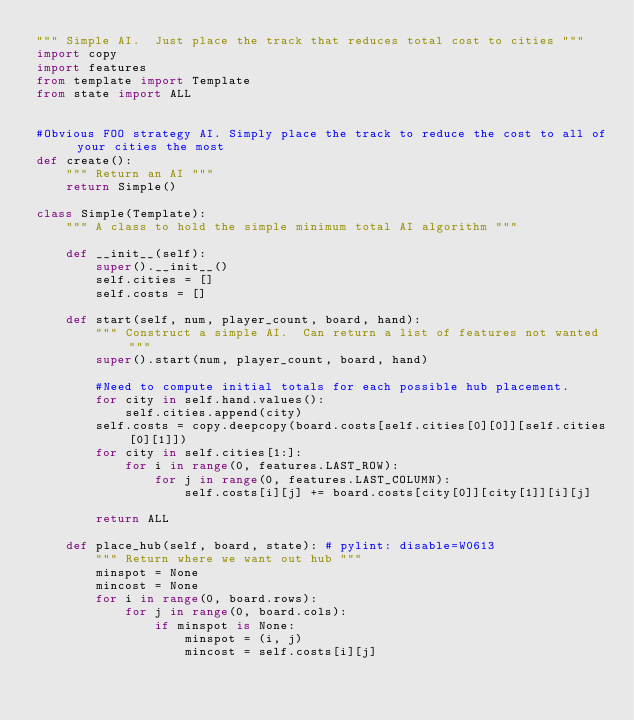Convert code to text. <code><loc_0><loc_0><loc_500><loc_500><_Python_>""" Simple AI.  Just place the track that reduces total cost to cities """
import copy
import features
from template import Template
from state import ALL


#Obvious FOO strategy AI. Simply place the track to reduce the cost to all of your cities the most
def create():
    """ Return an AI """
    return Simple()

class Simple(Template):
    """ A class to hold the simple minimum total AI algorithm """

    def __init__(self):
        super().__init__()
        self.cities = []
        self.costs = []

    def start(self, num, player_count, board, hand):
        """ Construct a simple AI.  Can return a list of features not wanted """
        super().start(num, player_count, board, hand)

        #Need to compute initial totals for each possible hub placement.
        for city in self.hand.values():
            self.cities.append(city)
        self.costs = copy.deepcopy(board.costs[self.cities[0][0]][self.cities[0][1]])
        for city in self.cities[1:]:
            for i in range(0, features.LAST_ROW):
                for j in range(0, features.LAST_COLUMN):
                    self.costs[i][j] += board.costs[city[0]][city[1]][i][j]

        return ALL

    def place_hub(self, board, state): # pylint: disable=W0613
        """ Return where we want out hub """
        minspot = None
        mincost = None
        for i in range(0, board.rows):
            for j in range(0, board.cols):
                if minspot is None:
                    minspot = (i, j)
                    mincost = self.costs[i][j]</code> 